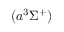Convert formula to latex. <formula><loc_0><loc_0><loc_500><loc_500>( a ^ { 3 } \Sigma ^ { + } )</formula> 